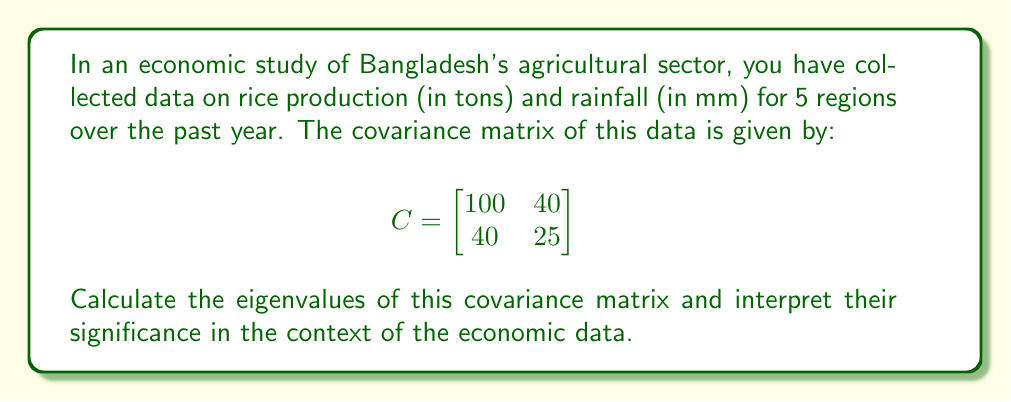What is the answer to this math problem? To find the eigenvalues of the covariance matrix, we need to solve the characteristic equation:

1) The characteristic equation is given by $\det(C - \lambda I) = 0$, where $I$ is the 2x2 identity matrix.

2) Expanding this:

   $$\det\begin{bmatrix}
   100 - \lambda & 40 \\
   40 & 25 - \lambda
   \end{bmatrix} = 0$$

3) Calculate the determinant:
   $(100 - \lambda)(25 - \lambda) - 40 \cdot 40 = 0$

4) Expand:
   $2500 - 125\lambda + \lambda^2 - 1600 = 0$
   $\lambda^2 - 125\lambda + 900 = 0$

5) This is a quadratic equation. We can solve it using the quadratic formula:
   $\lambda = \frac{-b \pm \sqrt{b^2 - 4ac}}{2a}$

   Where $a=1$, $b=-125$, and $c=900$

6) Solving:
   $\lambda = \frac{125 \pm \sqrt{125^2 - 4(1)(900)}}{2(1)}$
   $\lambda = \frac{125 \pm \sqrt{15625 - 3600}}{2}$
   $\lambda = \frac{125 \pm \sqrt{12025}}{2}$
   $\lambda = \frac{125 \pm 109.66}{2}$

7) Therefore, the eigenvalues are:
   $\lambda_1 = \frac{125 + 109.66}{2} \approx 117.33$
   $\lambda_2 = \frac{125 - 109.66}{2} \approx 7.67$

Interpretation: 
The larger eigenvalue (117.33) represents the direction of maximum variance in the data, which is likely along the rice production axis. This suggests that rice production varies more than rainfall across the regions.

The smaller eigenvalue (7.67) represents the direction of minimum variance, likely associated more with rainfall. This indicates less variation in rainfall across the regions.

The ratio of these eigenvalues (approximately 15:1) suggests that the data is considerably more spread out along one principal component than the other, indicating a strong correlation between rice production and rainfall in Bangladesh's agricultural sector.
Answer: Eigenvalues: $\lambda_1 \approx 117.33$, $\lambda_2 \approx 7.67$. Larger eigenvalue indicates greater variance in rice production; smaller eigenvalue suggests less variation in rainfall. 